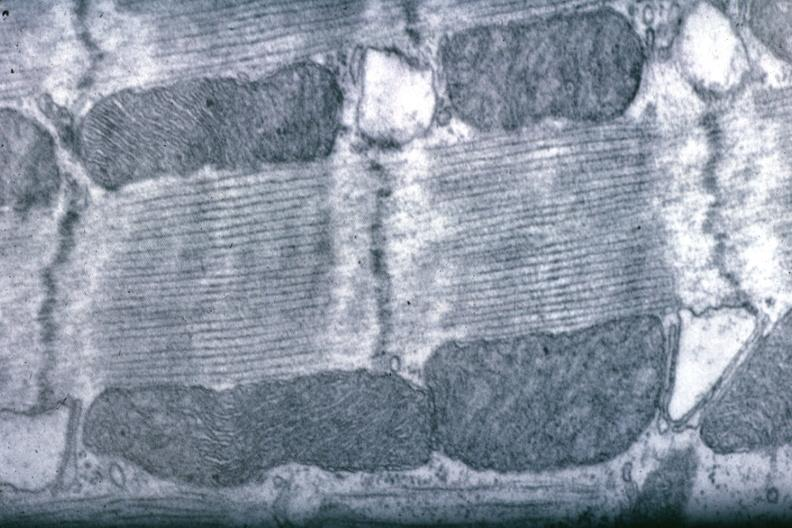does cardiovascular show good for banding pattern mitochondria?
Answer the question using a single word or phrase. No 